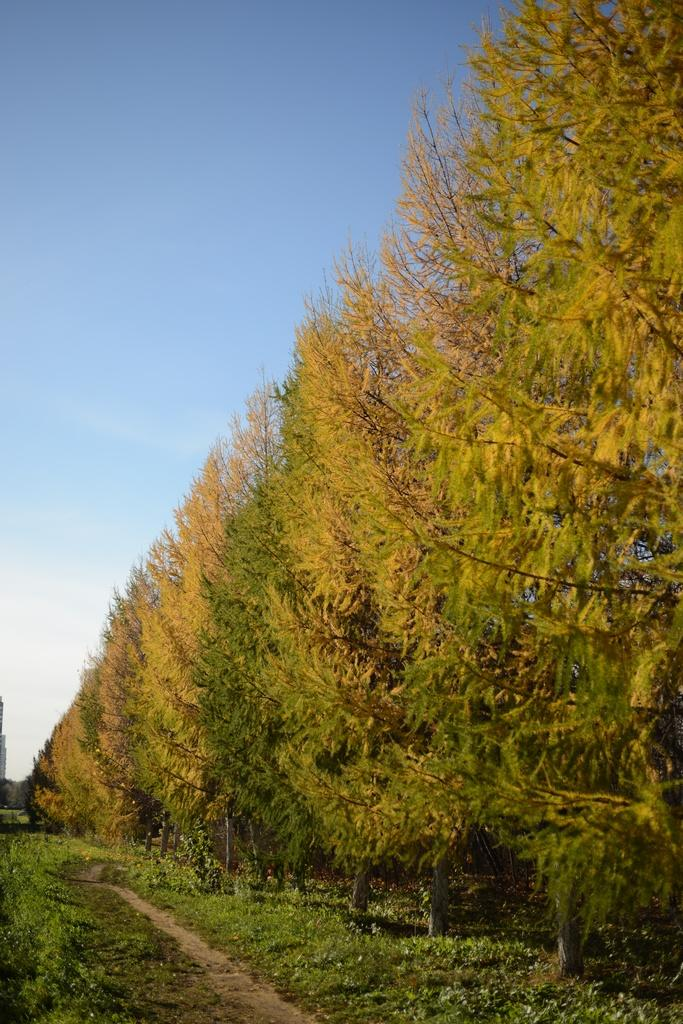What type of vegetation is present on the ground in the image? There is grass on the ground in the image. What feature is visible that people might walk on? There is a path in the image. What can be seen on the right side of the image? There are trees on the right side of the image. What color is the sky in the image? The sky is blue in color in the image. Can you tell me how many cables are hanging from the trees in the image? There are no cables visible in the image. Is there any prose written on the grass in the image? There is no prose visible on the grass in the image. 